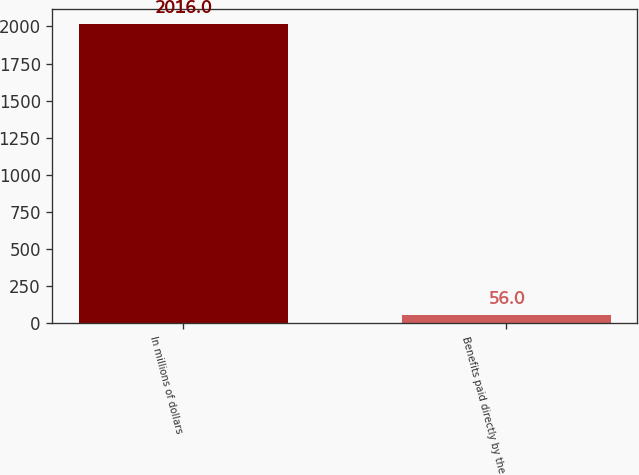Convert chart. <chart><loc_0><loc_0><loc_500><loc_500><bar_chart><fcel>In millions of dollars<fcel>Benefits paid directly by the<nl><fcel>2016<fcel>56<nl></chart> 